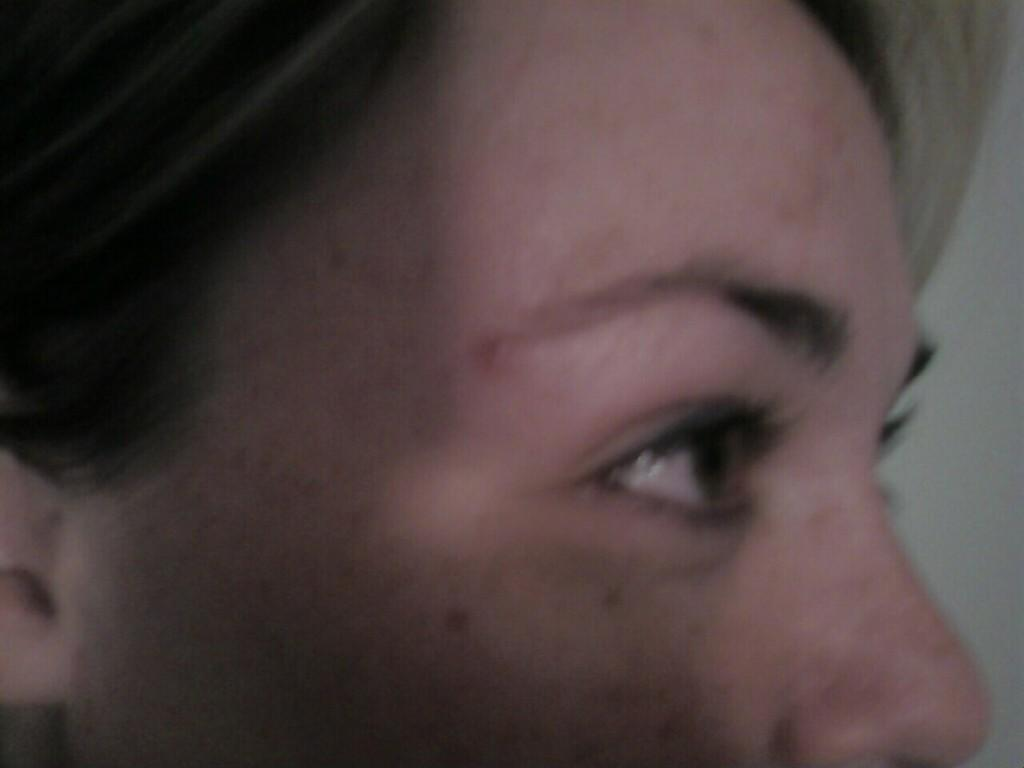What is the main subject of the image? The image shows the face of a person. Which facial features can be seen in the image? Only a single eye, one eyebrow, the nose, and one ear are visible. What can be observed about the person's hair in the image? Hair is visible in the image. What is the background of the image? There is a white wall on the right side of the image. How does the person's mind appear in the image? The person's mind is not visible in the image; only their face and hair are shown. 